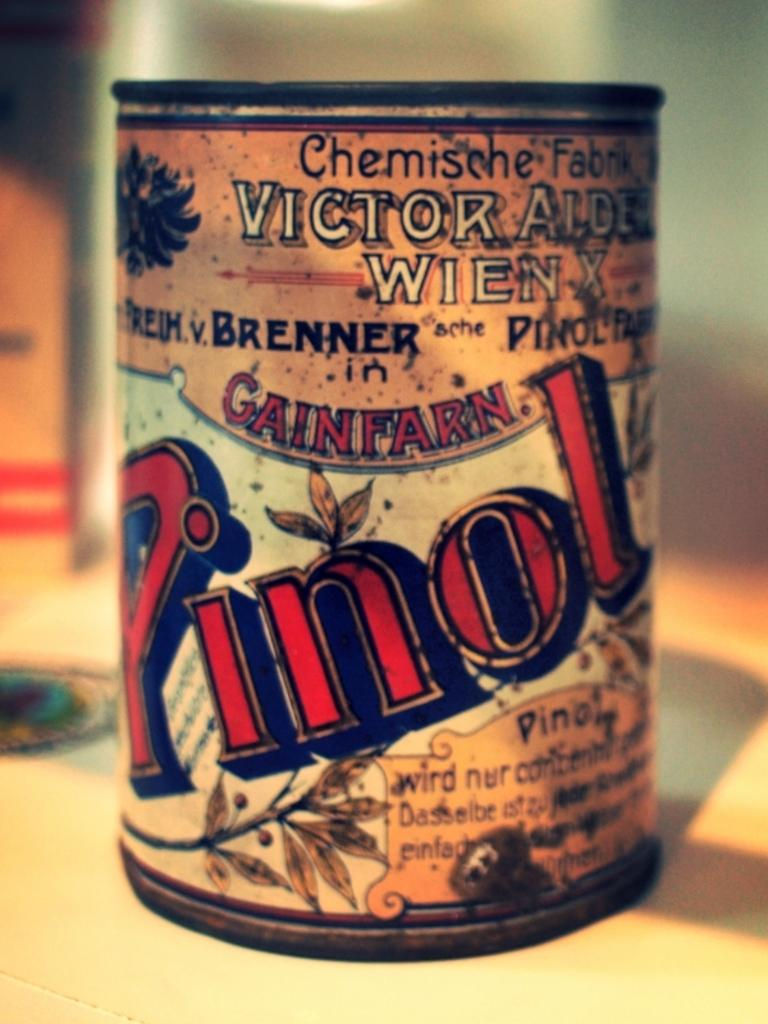<image>
Give a short and clear explanation of the subsequent image. An old rusty can of Pinol shows a little sprig of leaves over the letter "n". 